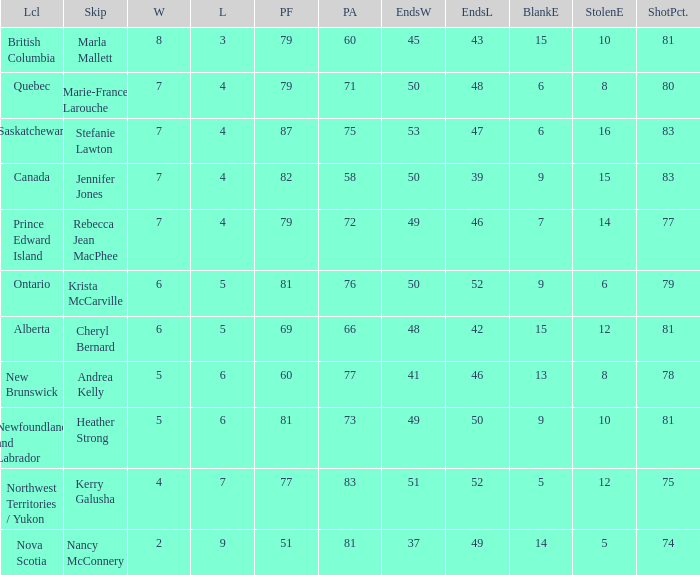Where was the shot pct 78? New Brunswick. 